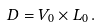Convert formula to latex. <formula><loc_0><loc_0><loc_500><loc_500>D = V _ { 0 } \times L _ { 0 } \, .</formula> 